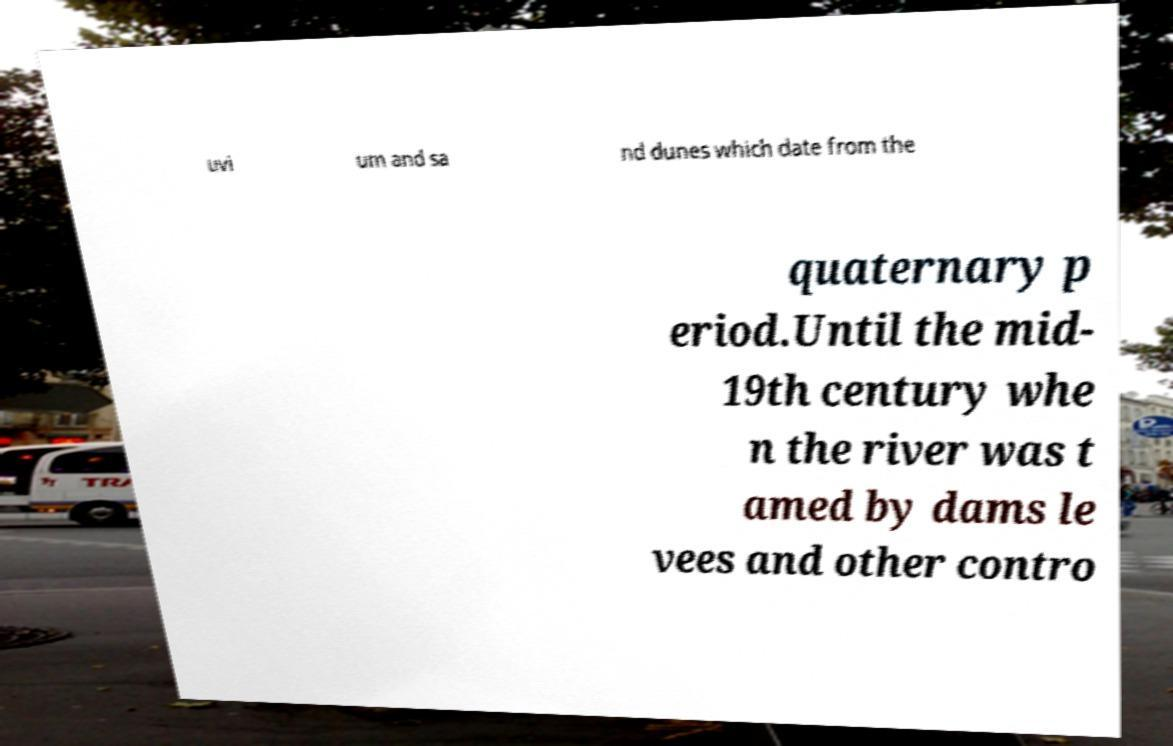Can you read and provide the text displayed in the image?This photo seems to have some interesting text. Can you extract and type it out for me? uvi um and sa nd dunes which date from the quaternary p eriod.Until the mid- 19th century whe n the river was t amed by dams le vees and other contro 